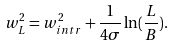Convert formula to latex. <formula><loc_0><loc_0><loc_500><loc_500>w _ { L } ^ { 2 } = w _ { i n t r } ^ { 2 } + \frac { 1 } { 4 \sigma } \ln ( \frac { L } { B } ) .</formula> 